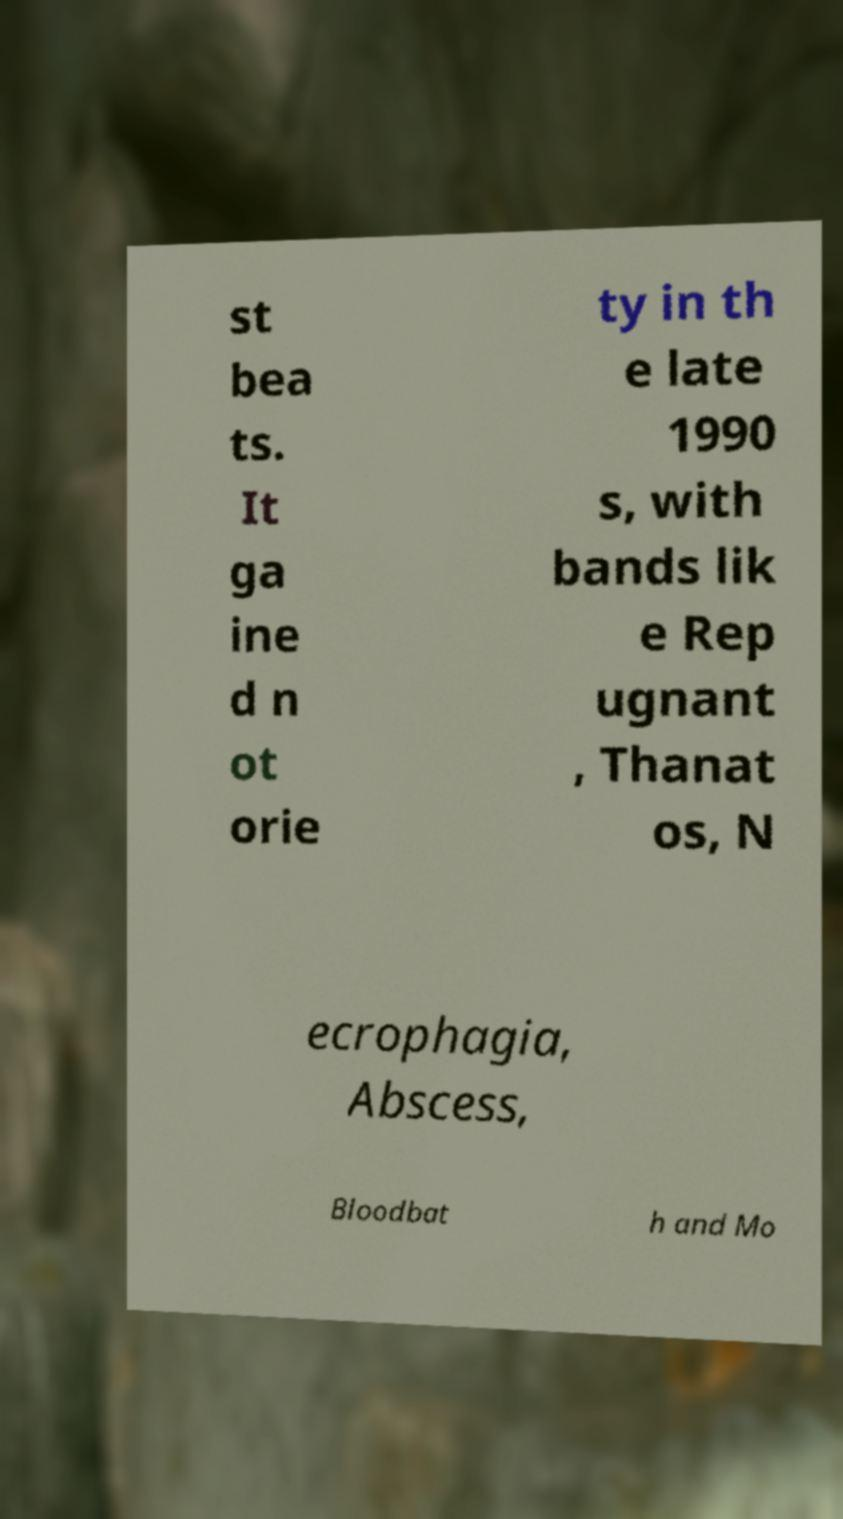Could you extract and type out the text from this image? st bea ts. It ga ine d n ot orie ty in th e late 1990 s, with bands lik e Rep ugnant , Thanat os, N ecrophagia, Abscess, Bloodbat h and Mo 